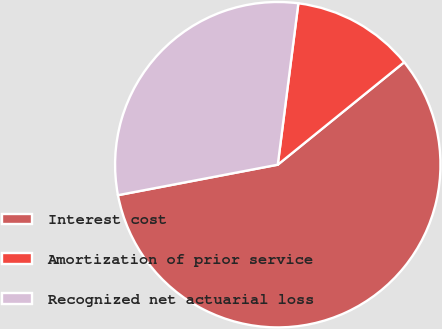<chart> <loc_0><loc_0><loc_500><loc_500><pie_chart><fcel>Interest cost<fcel>Amortization of prior service<fcel>Recognized net actuarial loss<nl><fcel>57.84%<fcel>12.14%<fcel>30.02%<nl></chart> 